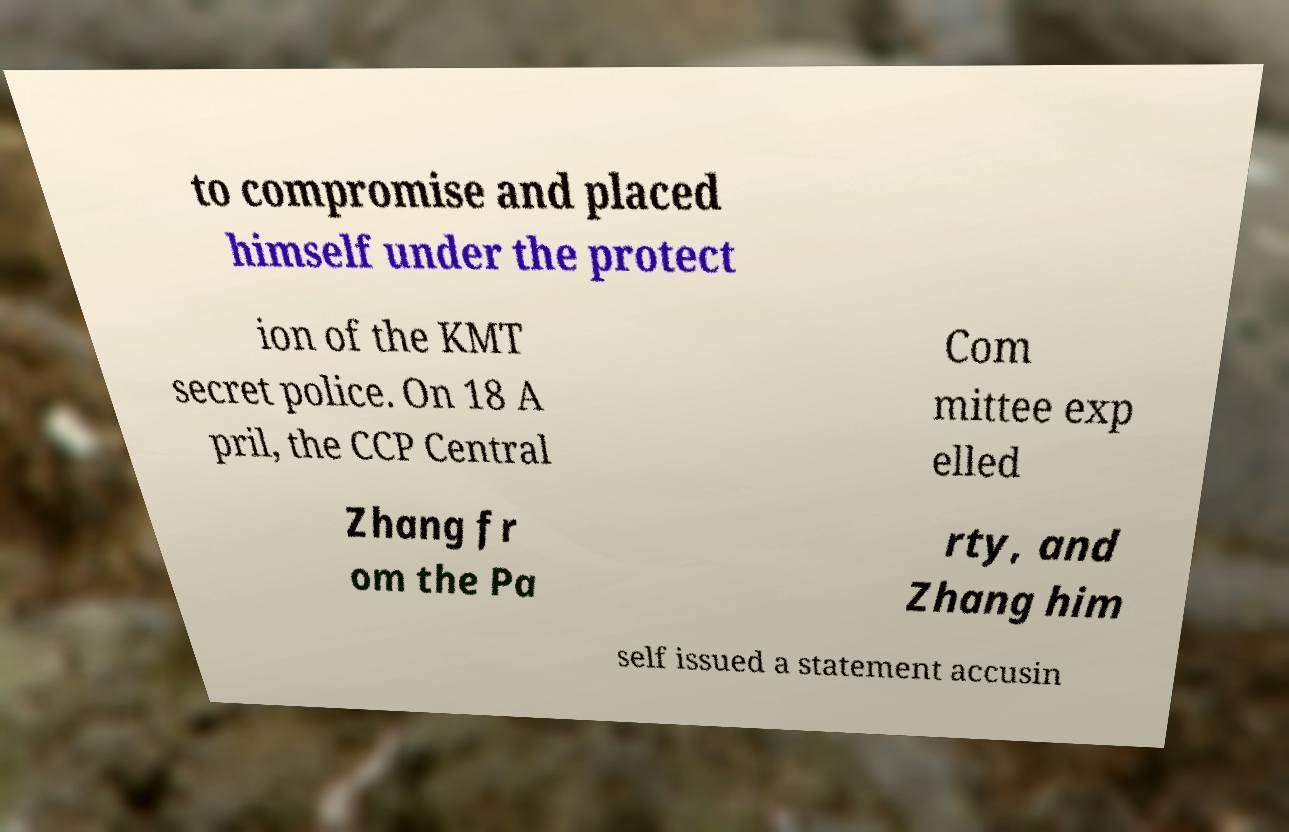Could you extract and type out the text from this image? to compromise and placed himself under the protect ion of the KMT secret police. On 18 A pril, the CCP Central Com mittee exp elled Zhang fr om the Pa rty, and Zhang him self issued a statement accusin 